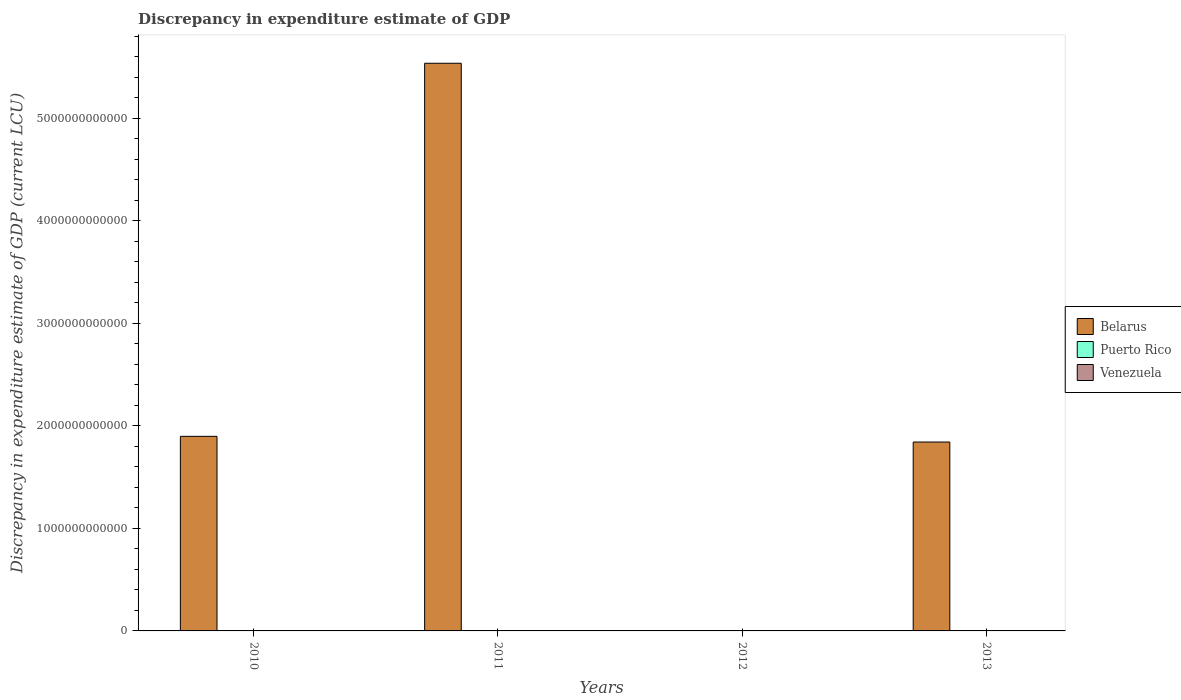What is the label of the 1st group of bars from the left?
Provide a succinct answer. 2010. In how many cases, is the number of bars for a given year not equal to the number of legend labels?
Keep it short and to the point. 3. What is the discrepancy in expenditure estimate of GDP in Belarus in 2011?
Ensure brevity in your answer.  5.54e+12. Across all years, what is the maximum discrepancy in expenditure estimate of GDP in Venezuela?
Offer a terse response. 0. In which year was the discrepancy in expenditure estimate of GDP in Belarus maximum?
Make the answer very short. 2011. What is the total discrepancy in expenditure estimate of GDP in Venezuela in the graph?
Give a very brief answer. 0. What is the difference between the discrepancy in expenditure estimate of GDP in Venezuela in 2011 and that in 2013?
Provide a succinct answer. -0. What is the average discrepancy in expenditure estimate of GDP in Venezuela per year?
Give a very brief answer. 0. In the year 2013, what is the difference between the discrepancy in expenditure estimate of GDP in Belarus and discrepancy in expenditure estimate of GDP in Venezuela?
Your response must be concise. 1.84e+12. What is the ratio of the discrepancy in expenditure estimate of GDP in Belarus in 2010 to that in 2013?
Keep it short and to the point. 1.03. Is the discrepancy in expenditure estimate of GDP in Puerto Rico in 2010 less than that in 2011?
Keep it short and to the point. Yes. Is the difference between the discrepancy in expenditure estimate of GDP in Belarus in 2011 and 2013 greater than the difference between the discrepancy in expenditure estimate of GDP in Venezuela in 2011 and 2013?
Your answer should be very brief. Yes. What is the difference between the highest and the lowest discrepancy in expenditure estimate of GDP in Belarus?
Make the answer very short. 5.54e+12. In how many years, is the discrepancy in expenditure estimate of GDP in Venezuela greater than the average discrepancy in expenditure estimate of GDP in Venezuela taken over all years?
Give a very brief answer. 2. Is the sum of the discrepancy in expenditure estimate of GDP in Belarus in 2010 and 2013 greater than the maximum discrepancy in expenditure estimate of GDP in Puerto Rico across all years?
Provide a short and direct response. Yes. Is it the case that in every year, the sum of the discrepancy in expenditure estimate of GDP in Puerto Rico and discrepancy in expenditure estimate of GDP in Venezuela is greater than the discrepancy in expenditure estimate of GDP in Belarus?
Offer a terse response. No. Are all the bars in the graph horizontal?
Your response must be concise. No. What is the difference between two consecutive major ticks on the Y-axis?
Your answer should be very brief. 1.00e+12. Are the values on the major ticks of Y-axis written in scientific E-notation?
Offer a terse response. No. Does the graph contain any zero values?
Your answer should be compact. Yes. Does the graph contain grids?
Provide a short and direct response. No. Where does the legend appear in the graph?
Ensure brevity in your answer.  Center right. What is the title of the graph?
Ensure brevity in your answer.  Discrepancy in expenditure estimate of GDP. What is the label or title of the X-axis?
Provide a succinct answer. Years. What is the label or title of the Y-axis?
Offer a terse response. Discrepancy in expenditure estimate of GDP (current LCU). What is the Discrepancy in expenditure estimate of GDP (current LCU) in Belarus in 2010?
Offer a very short reply. 1.90e+12. What is the Discrepancy in expenditure estimate of GDP (current LCU) in Puerto Rico in 2010?
Make the answer very short. 3.40e+04. What is the Discrepancy in expenditure estimate of GDP (current LCU) of Belarus in 2011?
Your response must be concise. 5.54e+12. What is the Discrepancy in expenditure estimate of GDP (current LCU) of Puerto Rico in 2011?
Your answer should be very brief. 1.13e+08. What is the Discrepancy in expenditure estimate of GDP (current LCU) in Venezuela in 2011?
Provide a short and direct response. 0. What is the Discrepancy in expenditure estimate of GDP (current LCU) in Puerto Rico in 2012?
Offer a terse response. 0. What is the Discrepancy in expenditure estimate of GDP (current LCU) in Venezuela in 2012?
Keep it short and to the point. 0. What is the Discrepancy in expenditure estimate of GDP (current LCU) in Belarus in 2013?
Your answer should be very brief. 1.84e+12. What is the Discrepancy in expenditure estimate of GDP (current LCU) in Venezuela in 2013?
Ensure brevity in your answer.  0. Across all years, what is the maximum Discrepancy in expenditure estimate of GDP (current LCU) in Belarus?
Ensure brevity in your answer.  5.54e+12. Across all years, what is the maximum Discrepancy in expenditure estimate of GDP (current LCU) of Puerto Rico?
Give a very brief answer. 1.13e+08. Across all years, what is the maximum Discrepancy in expenditure estimate of GDP (current LCU) of Venezuela?
Your response must be concise. 0. Across all years, what is the minimum Discrepancy in expenditure estimate of GDP (current LCU) in Venezuela?
Your answer should be very brief. 0. What is the total Discrepancy in expenditure estimate of GDP (current LCU) in Belarus in the graph?
Offer a very short reply. 9.28e+12. What is the total Discrepancy in expenditure estimate of GDP (current LCU) of Puerto Rico in the graph?
Your response must be concise. 1.13e+08. What is the difference between the Discrepancy in expenditure estimate of GDP (current LCU) of Belarus in 2010 and that in 2011?
Offer a terse response. -3.64e+12. What is the difference between the Discrepancy in expenditure estimate of GDP (current LCU) in Puerto Rico in 2010 and that in 2011?
Your response must be concise. -1.13e+08. What is the difference between the Discrepancy in expenditure estimate of GDP (current LCU) of Belarus in 2010 and that in 2013?
Ensure brevity in your answer.  5.57e+1. What is the difference between the Discrepancy in expenditure estimate of GDP (current LCU) in Belarus in 2011 and that in 2013?
Give a very brief answer. 3.70e+12. What is the difference between the Discrepancy in expenditure estimate of GDP (current LCU) of Venezuela in 2011 and that in 2013?
Offer a terse response. -0. What is the difference between the Discrepancy in expenditure estimate of GDP (current LCU) in Belarus in 2010 and the Discrepancy in expenditure estimate of GDP (current LCU) in Puerto Rico in 2011?
Offer a very short reply. 1.90e+12. What is the difference between the Discrepancy in expenditure estimate of GDP (current LCU) of Belarus in 2010 and the Discrepancy in expenditure estimate of GDP (current LCU) of Venezuela in 2011?
Provide a short and direct response. 1.90e+12. What is the difference between the Discrepancy in expenditure estimate of GDP (current LCU) in Puerto Rico in 2010 and the Discrepancy in expenditure estimate of GDP (current LCU) in Venezuela in 2011?
Your answer should be very brief. 3.40e+04. What is the difference between the Discrepancy in expenditure estimate of GDP (current LCU) in Belarus in 2010 and the Discrepancy in expenditure estimate of GDP (current LCU) in Venezuela in 2013?
Ensure brevity in your answer.  1.90e+12. What is the difference between the Discrepancy in expenditure estimate of GDP (current LCU) in Puerto Rico in 2010 and the Discrepancy in expenditure estimate of GDP (current LCU) in Venezuela in 2013?
Give a very brief answer. 3.40e+04. What is the difference between the Discrepancy in expenditure estimate of GDP (current LCU) in Belarus in 2011 and the Discrepancy in expenditure estimate of GDP (current LCU) in Venezuela in 2013?
Make the answer very short. 5.54e+12. What is the difference between the Discrepancy in expenditure estimate of GDP (current LCU) of Puerto Rico in 2011 and the Discrepancy in expenditure estimate of GDP (current LCU) of Venezuela in 2013?
Your response must be concise. 1.13e+08. What is the average Discrepancy in expenditure estimate of GDP (current LCU) in Belarus per year?
Keep it short and to the point. 2.32e+12. What is the average Discrepancy in expenditure estimate of GDP (current LCU) in Puerto Rico per year?
Make the answer very short. 2.82e+07. What is the average Discrepancy in expenditure estimate of GDP (current LCU) in Venezuela per year?
Make the answer very short. 0. In the year 2010, what is the difference between the Discrepancy in expenditure estimate of GDP (current LCU) in Belarus and Discrepancy in expenditure estimate of GDP (current LCU) in Puerto Rico?
Keep it short and to the point. 1.90e+12. In the year 2011, what is the difference between the Discrepancy in expenditure estimate of GDP (current LCU) of Belarus and Discrepancy in expenditure estimate of GDP (current LCU) of Puerto Rico?
Keep it short and to the point. 5.54e+12. In the year 2011, what is the difference between the Discrepancy in expenditure estimate of GDP (current LCU) in Belarus and Discrepancy in expenditure estimate of GDP (current LCU) in Venezuela?
Provide a short and direct response. 5.54e+12. In the year 2011, what is the difference between the Discrepancy in expenditure estimate of GDP (current LCU) in Puerto Rico and Discrepancy in expenditure estimate of GDP (current LCU) in Venezuela?
Provide a short and direct response. 1.13e+08. In the year 2013, what is the difference between the Discrepancy in expenditure estimate of GDP (current LCU) of Belarus and Discrepancy in expenditure estimate of GDP (current LCU) of Venezuela?
Offer a very short reply. 1.84e+12. What is the ratio of the Discrepancy in expenditure estimate of GDP (current LCU) in Belarus in 2010 to that in 2011?
Make the answer very short. 0.34. What is the ratio of the Discrepancy in expenditure estimate of GDP (current LCU) of Puerto Rico in 2010 to that in 2011?
Give a very brief answer. 0. What is the ratio of the Discrepancy in expenditure estimate of GDP (current LCU) of Belarus in 2010 to that in 2013?
Provide a short and direct response. 1.03. What is the ratio of the Discrepancy in expenditure estimate of GDP (current LCU) in Belarus in 2011 to that in 2013?
Give a very brief answer. 3.01. What is the ratio of the Discrepancy in expenditure estimate of GDP (current LCU) in Venezuela in 2011 to that in 2013?
Provide a short and direct response. 0.44. What is the difference between the highest and the second highest Discrepancy in expenditure estimate of GDP (current LCU) in Belarus?
Keep it short and to the point. 3.64e+12. What is the difference between the highest and the lowest Discrepancy in expenditure estimate of GDP (current LCU) in Belarus?
Offer a very short reply. 5.54e+12. What is the difference between the highest and the lowest Discrepancy in expenditure estimate of GDP (current LCU) of Puerto Rico?
Your answer should be very brief. 1.13e+08. What is the difference between the highest and the lowest Discrepancy in expenditure estimate of GDP (current LCU) in Venezuela?
Your response must be concise. 0. 